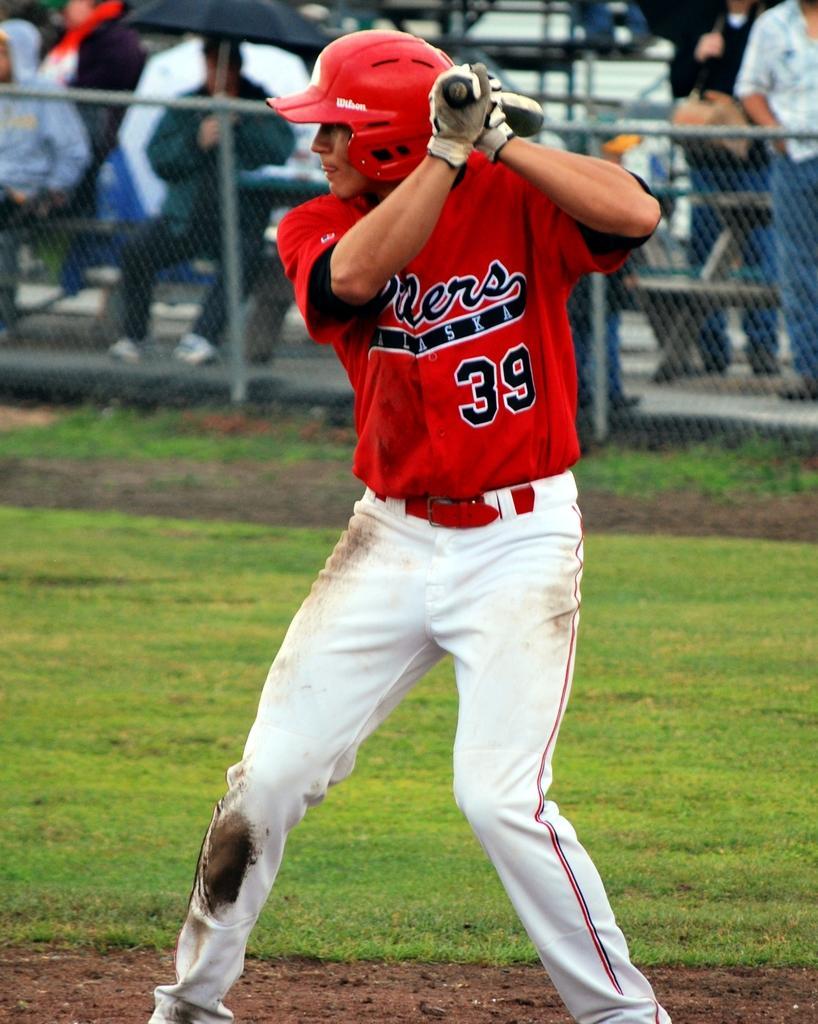Can you describe this image briefly? In the picture we can see a man standing on the ground and he is wearing a red T-shirt and a helmet and holding a stick and wearing a white glove and behind it, we can see a railing and people sitting and standing behind it and on the ground we can see a grass. 